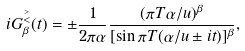<formula> <loc_0><loc_0><loc_500><loc_500>i G ^ { \stackrel { > } { < } } _ { \beta } ( t ) = \pm \frac { 1 } { 2 \pi \alpha } \frac { ( \pi T \alpha / u ) ^ { \beta } } { [ \sin \pi T ( \alpha / u \pm i t ) ] ^ { \beta } } ,</formula> 